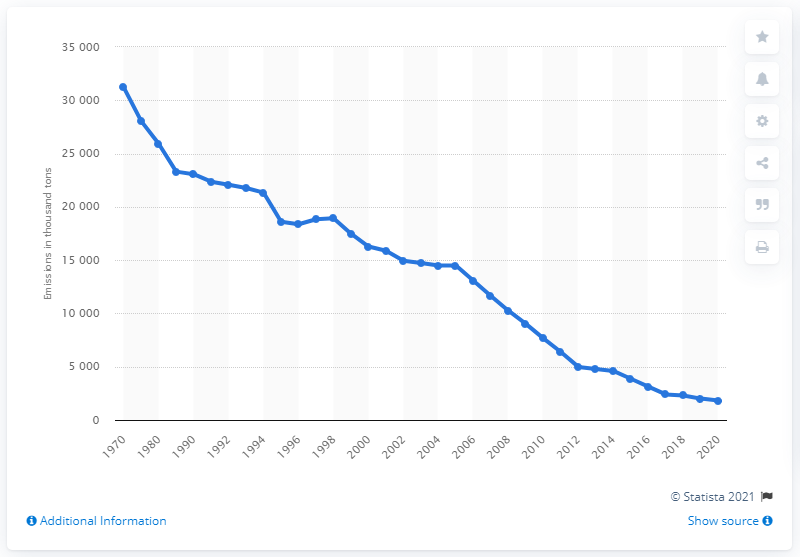Outline some significant characteristics in this image. In 1970, a total of 31.2 million tons of SO2 emissions were produced in the United States. 